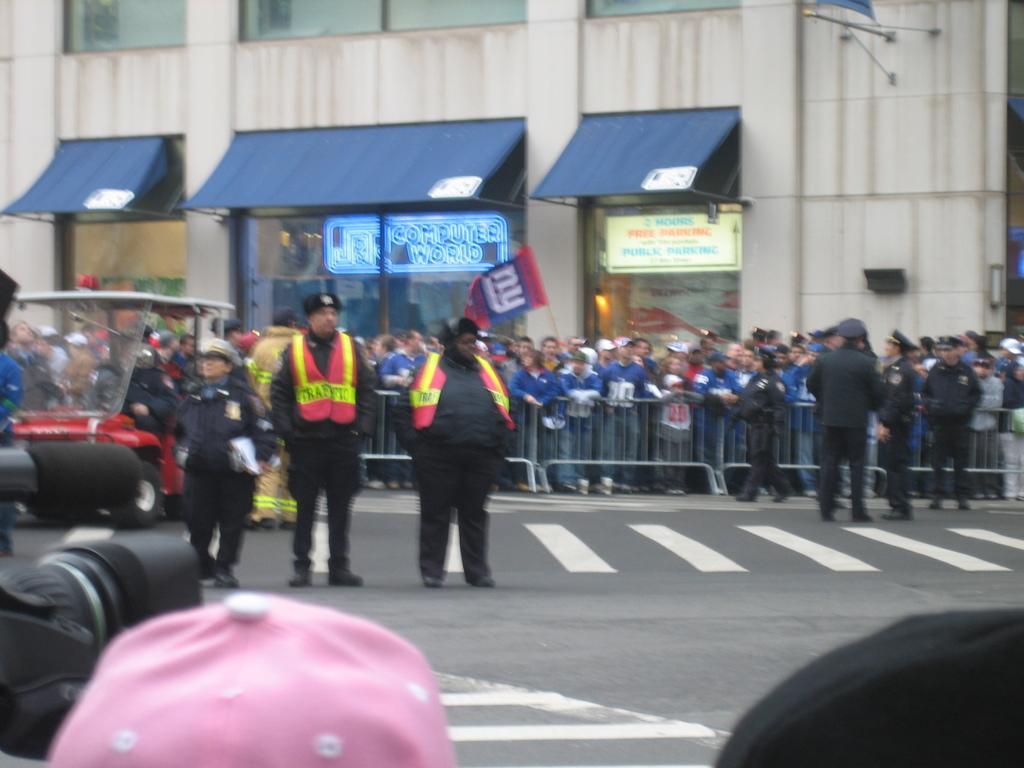Please provide a concise description of this image. In this image we can see so many people and barriers. At the bottom of the image, we can see the road. On the left side of the image, we can see a vehicle and a camera. At the top of the image, we can see a building. 